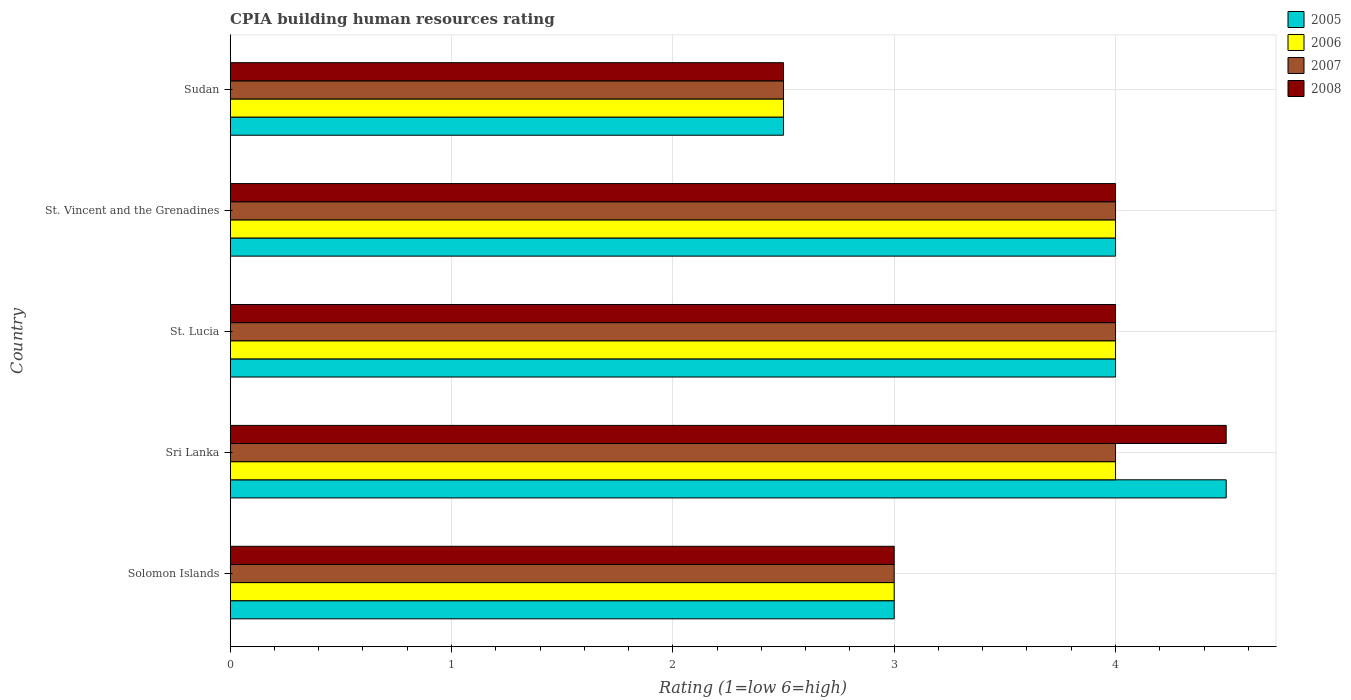How many groups of bars are there?
Provide a short and direct response. 5. What is the label of the 3rd group of bars from the top?
Offer a terse response. St. Lucia. Across all countries, what is the maximum CPIA rating in 2007?
Your response must be concise. 4. In which country was the CPIA rating in 2008 maximum?
Your answer should be compact. Sri Lanka. In which country was the CPIA rating in 2005 minimum?
Provide a succinct answer. Sudan. What is the total CPIA rating in 2007 in the graph?
Ensure brevity in your answer.  17.5. What is the difference between the CPIA rating in 2007 in Sri Lanka and that in St. Lucia?
Make the answer very short. 0. What is the average CPIA rating in 2006 per country?
Offer a terse response. 3.5. In how many countries, is the CPIA rating in 2005 greater than 0.8 ?
Ensure brevity in your answer.  5. Is the difference between the CPIA rating in 2006 in St. Lucia and St. Vincent and the Grenadines greater than the difference between the CPIA rating in 2007 in St. Lucia and St. Vincent and the Grenadines?
Your response must be concise. No. What is the difference between the highest and the second highest CPIA rating in 2008?
Your answer should be compact. 0.5. In how many countries, is the CPIA rating in 2008 greater than the average CPIA rating in 2008 taken over all countries?
Provide a succinct answer. 3. What does the 1st bar from the top in Sudan represents?
Offer a very short reply. 2008. Is it the case that in every country, the sum of the CPIA rating in 2008 and CPIA rating in 2006 is greater than the CPIA rating in 2005?
Your answer should be very brief. Yes. Are all the bars in the graph horizontal?
Offer a very short reply. Yes. What is the difference between two consecutive major ticks on the X-axis?
Give a very brief answer. 1. Does the graph contain any zero values?
Provide a short and direct response. No. Where does the legend appear in the graph?
Offer a terse response. Top right. How many legend labels are there?
Provide a short and direct response. 4. What is the title of the graph?
Offer a very short reply. CPIA building human resources rating. Does "2000" appear as one of the legend labels in the graph?
Keep it short and to the point. No. What is the label or title of the Y-axis?
Offer a very short reply. Country. What is the Rating (1=low 6=high) in 2005 in Solomon Islands?
Provide a succinct answer. 3. What is the Rating (1=low 6=high) in 2008 in Solomon Islands?
Provide a short and direct response. 3. What is the Rating (1=low 6=high) of 2005 in Sri Lanka?
Give a very brief answer. 4.5. What is the Rating (1=low 6=high) in 2007 in Sri Lanka?
Ensure brevity in your answer.  4. What is the Rating (1=low 6=high) of 2008 in Sri Lanka?
Your response must be concise. 4.5. What is the Rating (1=low 6=high) in 2005 in St. Lucia?
Give a very brief answer. 4. What is the Rating (1=low 6=high) of 2006 in St. Lucia?
Offer a very short reply. 4. What is the Rating (1=low 6=high) of 2006 in St. Vincent and the Grenadines?
Provide a short and direct response. 4. What is the Rating (1=low 6=high) in 2007 in St. Vincent and the Grenadines?
Your response must be concise. 4. What is the Rating (1=low 6=high) in 2005 in Sudan?
Ensure brevity in your answer.  2.5. What is the Rating (1=low 6=high) in 2006 in Sudan?
Give a very brief answer. 2.5. What is the Rating (1=low 6=high) of 2007 in Sudan?
Your response must be concise. 2.5. Across all countries, what is the maximum Rating (1=low 6=high) of 2005?
Keep it short and to the point. 4.5. Across all countries, what is the maximum Rating (1=low 6=high) in 2006?
Give a very brief answer. 4. Across all countries, what is the maximum Rating (1=low 6=high) of 2007?
Your answer should be very brief. 4. Across all countries, what is the minimum Rating (1=low 6=high) in 2005?
Your answer should be compact. 2.5. Across all countries, what is the minimum Rating (1=low 6=high) in 2008?
Provide a short and direct response. 2.5. What is the total Rating (1=low 6=high) of 2007 in the graph?
Keep it short and to the point. 17.5. What is the difference between the Rating (1=low 6=high) of 2005 in Solomon Islands and that in Sri Lanka?
Ensure brevity in your answer.  -1.5. What is the difference between the Rating (1=low 6=high) in 2008 in Solomon Islands and that in Sri Lanka?
Keep it short and to the point. -1.5. What is the difference between the Rating (1=low 6=high) of 2005 in Solomon Islands and that in St. Lucia?
Offer a very short reply. -1. What is the difference between the Rating (1=low 6=high) in 2007 in Solomon Islands and that in St. Lucia?
Offer a very short reply. -1. What is the difference between the Rating (1=low 6=high) in 2005 in Solomon Islands and that in St. Vincent and the Grenadines?
Your response must be concise. -1. What is the difference between the Rating (1=low 6=high) in 2006 in Solomon Islands and that in St. Vincent and the Grenadines?
Your response must be concise. -1. What is the difference between the Rating (1=low 6=high) in 2008 in Solomon Islands and that in St. Vincent and the Grenadines?
Provide a succinct answer. -1. What is the difference between the Rating (1=low 6=high) of 2005 in Solomon Islands and that in Sudan?
Your answer should be very brief. 0.5. What is the difference between the Rating (1=low 6=high) in 2007 in Solomon Islands and that in Sudan?
Your answer should be very brief. 0.5. What is the difference between the Rating (1=low 6=high) of 2008 in Solomon Islands and that in Sudan?
Make the answer very short. 0.5. What is the difference between the Rating (1=low 6=high) of 2005 in Sri Lanka and that in St. Lucia?
Make the answer very short. 0.5. What is the difference between the Rating (1=low 6=high) of 2006 in Sri Lanka and that in St. Lucia?
Provide a short and direct response. 0. What is the difference between the Rating (1=low 6=high) in 2007 in Sri Lanka and that in St. Lucia?
Make the answer very short. 0. What is the difference between the Rating (1=low 6=high) of 2008 in Sri Lanka and that in St. Lucia?
Provide a short and direct response. 0.5. What is the difference between the Rating (1=low 6=high) of 2005 in Sri Lanka and that in St. Vincent and the Grenadines?
Ensure brevity in your answer.  0.5. What is the difference between the Rating (1=low 6=high) of 2006 in Sri Lanka and that in St. Vincent and the Grenadines?
Offer a very short reply. 0. What is the difference between the Rating (1=low 6=high) of 2006 in Sri Lanka and that in Sudan?
Make the answer very short. 1.5. What is the difference between the Rating (1=low 6=high) of 2005 in St. Lucia and that in St. Vincent and the Grenadines?
Your answer should be very brief. 0. What is the difference between the Rating (1=low 6=high) of 2008 in St. Lucia and that in St. Vincent and the Grenadines?
Provide a short and direct response. 0. What is the difference between the Rating (1=low 6=high) in 2005 in St. Lucia and that in Sudan?
Offer a very short reply. 1.5. What is the difference between the Rating (1=low 6=high) in 2006 in St. Lucia and that in Sudan?
Ensure brevity in your answer.  1.5. What is the difference between the Rating (1=low 6=high) in 2007 in St. Vincent and the Grenadines and that in Sudan?
Give a very brief answer. 1.5. What is the difference between the Rating (1=low 6=high) of 2008 in St. Vincent and the Grenadines and that in Sudan?
Keep it short and to the point. 1.5. What is the difference between the Rating (1=low 6=high) in 2006 in Solomon Islands and the Rating (1=low 6=high) in 2008 in Sri Lanka?
Your answer should be very brief. -1.5. What is the difference between the Rating (1=low 6=high) in 2007 in Solomon Islands and the Rating (1=low 6=high) in 2008 in Sri Lanka?
Your answer should be compact. -1.5. What is the difference between the Rating (1=low 6=high) of 2005 in Solomon Islands and the Rating (1=low 6=high) of 2006 in St. Lucia?
Your answer should be compact. -1. What is the difference between the Rating (1=low 6=high) of 2005 in Solomon Islands and the Rating (1=low 6=high) of 2008 in St. Lucia?
Offer a very short reply. -1. What is the difference between the Rating (1=low 6=high) in 2005 in Solomon Islands and the Rating (1=low 6=high) in 2008 in St. Vincent and the Grenadines?
Offer a very short reply. -1. What is the difference between the Rating (1=low 6=high) in 2007 in Solomon Islands and the Rating (1=low 6=high) in 2008 in St. Vincent and the Grenadines?
Make the answer very short. -1. What is the difference between the Rating (1=low 6=high) of 2005 in Solomon Islands and the Rating (1=low 6=high) of 2006 in Sudan?
Give a very brief answer. 0.5. What is the difference between the Rating (1=low 6=high) in 2005 in Solomon Islands and the Rating (1=low 6=high) in 2008 in Sudan?
Your answer should be very brief. 0.5. What is the difference between the Rating (1=low 6=high) in 2006 in Solomon Islands and the Rating (1=low 6=high) in 2007 in Sudan?
Your response must be concise. 0.5. What is the difference between the Rating (1=low 6=high) in 2006 in Solomon Islands and the Rating (1=low 6=high) in 2008 in Sudan?
Offer a terse response. 0.5. What is the difference between the Rating (1=low 6=high) in 2007 in Solomon Islands and the Rating (1=low 6=high) in 2008 in Sudan?
Provide a succinct answer. 0.5. What is the difference between the Rating (1=low 6=high) of 2005 in Sri Lanka and the Rating (1=low 6=high) of 2006 in St. Lucia?
Keep it short and to the point. 0.5. What is the difference between the Rating (1=low 6=high) in 2005 in Sri Lanka and the Rating (1=low 6=high) in 2008 in St. Lucia?
Make the answer very short. 0.5. What is the difference between the Rating (1=low 6=high) in 2006 in Sri Lanka and the Rating (1=low 6=high) in 2008 in St. Lucia?
Your answer should be compact. 0. What is the difference between the Rating (1=low 6=high) in 2007 in Sri Lanka and the Rating (1=low 6=high) in 2008 in St. Lucia?
Keep it short and to the point. 0. What is the difference between the Rating (1=low 6=high) of 2005 in Sri Lanka and the Rating (1=low 6=high) of 2008 in St. Vincent and the Grenadines?
Your answer should be compact. 0.5. What is the difference between the Rating (1=low 6=high) in 2006 in Sri Lanka and the Rating (1=low 6=high) in 2007 in St. Vincent and the Grenadines?
Your response must be concise. 0. What is the difference between the Rating (1=low 6=high) of 2006 in Sri Lanka and the Rating (1=low 6=high) of 2008 in St. Vincent and the Grenadines?
Ensure brevity in your answer.  0. What is the difference between the Rating (1=low 6=high) of 2006 in Sri Lanka and the Rating (1=low 6=high) of 2007 in Sudan?
Your answer should be very brief. 1.5. What is the difference between the Rating (1=low 6=high) of 2005 in St. Lucia and the Rating (1=low 6=high) of 2007 in St. Vincent and the Grenadines?
Your answer should be compact. 0. What is the difference between the Rating (1=low 6=high) in 2005 in St. Lucia and the Rating (1=low 6=high) in 2008 in St. Vincent and the Grenadines?
Provide a succinct answer. 0. What is the difference between the Rating (1=low 6=high) of 2006 in St. Lucia and the Rating (1=low 6=high) of 2007 in St. Vincent and the Grenadines?
Your response must be concise. 0. What is the difference between the Rating (1=low 6=high) of 2007 in St. Lucia and the Rating (1=low 6=high) of 2008 in St. Vincent and the Grenadines?
Keep it short and to the point. 0. What is the difference between the Rating (1=low 6=high) in 2005 in St. Lucia and the Rating (1=low 6=high) in 2006 in Sudan?
Your response must be concise. 1.5. What is the difference between the Rating (1=low 6=high) in 2005 in St. Lucia and the Rating (1=low 6=high) in 2007 in Sudan?
Keep it short and to the point. 1.5. What is the difference between the Rating (1=low 6=high) in 2005 in St. Lucia and the Rating (1=low 6=high) in 2008 in Sudan?
Offer a very short reply. 1.5. What is the difference between the Rating (1=low 6=high) of 2007 in St. Lucia and the Rating (1=low 6=high) of 2008 in Sudan?
Keep it short and to the point. 1.5. What is the difference between the Rating (1=low 6=high) of 2005 in St. Vincent and the Grenadines and the Rating (1=low 6=high) of 2006 in Sudan?
Give a very brief answer. 1.5. What is the difference between the Rating (1=low 6=high) in 2005 in St. Vincent and the Grenadines and the Rating (1=low 6=high) in 2007 in Sudan?
Your answer should be very brief. 1.5. What is the difference between the Rating (1=low 6=high) of 2005 in St. Vincent and the Grenadines and the Rating (1=low 6=high) of 2008 in Sudan?
Provide a short and direct response. 1.5. What is the difference between the Rating (1=low 6=high) in 2006 in St. Vincent and the Grenadines and the Rating (1=low 6=high) in 2008 in Sudan?
Ensure brevity in your answer.  1.5. What is the difference between the Rating (1=low 6=high) in 2007 in St. Vincent and the Grenadines and the Rating (1=low 6=high) in 2008 in Sudan?
Provide a short and direct response. 1.5. What is the average Rating (1=low 6=high) in 2005 per country?
Ensure brevity in your answer.  3.6. What is the average Rating (1=low 6=high) of 2006 per country?
Offer a terse response. 3.5. What is the average Rating (1=low 6=high) of 2008 per country?
Your response must be concise. 3.6. What is the difference between the Rating (1=low 6=high) in 2005 and Rating (1=low 6=high) in 2006 in Solomon Islands?
Provide a succinct answer. 0. What is the difference between the Rating (1=low 6=high) in 2005 and Rating (1=low 6=high) in 2007 in Solomon Islands?
Offer a terse response. 0. What is the difference between the Rating (1=low 6=high) in 2005 and Rating (1=low 6=high) in 2008 in Solomon Islands?
Ensure brevity in your answer.  0. What is the difference between the Rating (1=low 6=high) in 2006 and Rating (1=low 6=high) in 2007 in Solomon Islands?
Your answer should be very brief. 0. What is the difference between the Rating (1=low 6=high) in 2007 and Rating (1=low 6=high) in 2008 in Solomon Islands?
Make the answer very short. 0. What is the difference between the Rating (1=low 6=high) of 2005 and Rating (1=low 6=high) of 2006 in Sri Lanka?
Provide a short and direct response. 0.5. What is the difference between the Rating (1=low 6=high) of 2005 and Rating (1=low 6=high) of 2008 in Sri Lanka?
Your answer should be very brief. 0. What is the difference between the Rating (1=low 6=high) of 2006 and Rating (1=low 6=high) of 2007 in Sri Lanka?
Make the answer very short. 0. What is the difference between the Rating (1=low 6=high) of 2007 and Rating (1=low 6=high) of 2008 in Sri Lanka?
Provide a succinct answer. -0.5. What is the difference between the Rating (1=low 6=high) of 2005 and Rating (1=low 6=high) of 2006 in St. Lucia?
Provide a succinct answer. 0. What is the difference between the Rating (1=low 6=high) in 2005 and Rating (1=low 6=high) in 2007 in St. Lucia?
Your answer should be very brief. 0. What is the difference between the Rating (1=low 6=high) of 2005 and Rating (1=low 6=high) of 2008 in St. Lucia?
Give a very brief answer. 0. What is the difference between the Rating (1=low 6=high) in 2006 and Rating (1=low 6=high) in 2007 in St. Lucia?
Provide a succinct answer. 0. What is the difference between the Rating (1=low 6=high) of 2006 and Rating (1=low 6=high) of 2008 in St. Lucia?
Your response must be concise. 0. What is the difference between the Rating (1=low 6=high) of 2007 and Rating (1=low 6=high) of 2008 in St. Lucia?
Offer a terse response. 0. What is the difference between the Rating (1=low 6=high) of 2005 and Rating (1=low 6=high) of 2007 in St. Vincent and the Grenadines?
Offer a terse response. 0. What is the difference between the Rating (1=low 6=high) of 2005 and Rating (1=low 6=high) of 2008 in St. Vincent and the Grenadines?
Provide a succinct answer. 0. What is the difference between the Rating (1=low 6=high) of 2006 and Rating (1=low 6=high) of 2008 in St. Vincent and the Grenadines?
Give a very brief answer. 0. What is the difference between the Rating (1=low 6=high) of 2005 and Rating (1=low 6=high) of 2007 in Sudan?
Give a very brief answer. 0. What is the difference between the Rating (1=low 6=high) of 2005 and Rating (1=low 6=high) of 2008 in Sudan?
Make the answer very short. 0. What is the difference between the Rating (1=low 6=high) in 2006 and Rating (1=low 6=high) in 2007 in Sudan?
Provide a succinct answer. 0. What is the ratio of the Rating (1=low 6=high) in 2005 in Solomon Islands to that in Sri Lanka?
Your answer should be compact. 0.67. What is the ratio of the Rating (1=low 6=high) in 2006 in Solomon Islands to that in Sri Lanka?
Give a very brief answer. 0.75. What is the ratio of the Rating (1=low 6=high) in 2005 in Solomon Islands to that in St. Lucia?
Make the answer very short. 0.75. What is the ratio of the Rating (1=low 6=high) in 2006 in Solomon Islands to that in St. Lucia?
Your response must be concise. 0.75. What is the ratio of the Rating (1=low 6=high) in 2007 in Solomon Islands to that in St. Lucia?
Offer a terse response. 0.75. What is the ratio of the Rating (1=low 6=high) in 2005 in Solomon Islands to that in St. Vincent and the Grenadines?
Provide a succinct answer. 0.75. What is the ratio of the Rating (1=low 6=high) of 2006 in Solomon Islands to that in St. Vincent and the Grenadines?
Give a very brief answer. 0.75. What is the ratio of the Rating (1=low 6=high) in 2007 in Solomon Islands to that in St. Vincent and the Grenadines?
Ensure brevity in your answer.  0.75. What is the ratio of the Rating (1=low 6=high) of 2008 in Solomon Islands to that in St. Vincent and the Grenadines?
Offer a very short reply. 0.75. What is the ratio of the Rating (1=low 6=high) of 2008 in Solomon Islands to that in Sudan?
Provide a succinct answer. 1.2. What is the ratio of the Rating (1=low 6=high) in 2005 in Sri Lanka to that in St. Lucia?
Offer a very short reply. 1.12. What is the ratio of the Rating (1=low 6=high) in 2006 in Sri Lanka to that in St. Lucia?
Offer a terse response. 1. What is the ratio of the Rating (1=low 6=high) of 2008 in Sri Lanka to that in St. Lucia?
Your response must be concise. 1.12. What is the ratio of the Rating (1=low 6=high) in 2005 in Sri Lanka to that in St. Vincent and the Grenadines?
Your response must be concise. 1.12. What is the ratio of the Rating (1=low 6=high) of 2006 in Sri Lanka to that in St. Vincent and the Grenadines?
Keep it short and to the point. 1. What is the ratio of the Rating (1=low 6=high) of 2007 in Sri Lanka to that in St. Vincent and the Grenadines?
Offer a very short reply. 1. What is the ratio of the Rating (1=low 6=high) of 2008 in Sri Lanka to that in St. Vincent and the Grenadines?
Your response must be concise. 1.12. What is the ratio of the Rating (1=low 6=high) of 2006 in Sri Lanka to that in Sudan?
Your answer should be compact. 1.6. What is the ratio of the Rating (1=low 6=high) of 2007 in Sri Lanka to that in Sudan?
Provide a succinct answer. 1.6. What is the ratio of the Rating (1=low 6=high) of 2008 in St. Lucia to that in St. Vincent and the Grenadines?
Give a very brief answer. 1. What is the ratio of the Rating (1=low 6=high) in 2005 in St. Lucia to that in Sudan?
Ensure brevity in your answer.  1.6. What is the ratio of the Rating (1=low 6=high) in 2007 in St. Lucia to that in Sudan?
Your response must be concise. 1.6. What is the ratio of the Rating (1=low 6=high) in 2008 in St. Lucia to that in Sudan?
Your answer should be very brief. 1.6. What is the ratio of the Rating (1=low 6=high) of 2007 in St. Vincent and the Grenadines to that in Sudan?
Give a very brief answer. 1.6. What is the ratio of the Rating (1=low 6=high) of 2008 in St. Vincent and the Grenadines to that in Sudan?
Make the answer very short. 1.6. What is the difference between the highest and the second highest Rating (1=low 6=high) of 2005?
Give a very brief answer. 0.5. What is the difference between the highest and the second highest Rating (1=low 6=high) in 2006?
Ensure brevity in your answer.  0. What is the difference between the highest and the second highest Rating (1=low 6=high) in 2007?
Make the answer very short. 0. What is the difference between the highest and the second highest Rating (1=low 6=high) of 2008?
Your answer should be compact. 0.5. What is the difference between the highest and the lowest Rating (1=low 6=high) of 2005?
Your response must be concise. 2. What is the difference between the highest and the lowest Rating (1=low 6=high) of 2006?
Provide a succinct answer. 1.5. What is the difference between the highest and the lowest Rating (1=low 6=high) of 2008?
Offer a terse response. 2. 